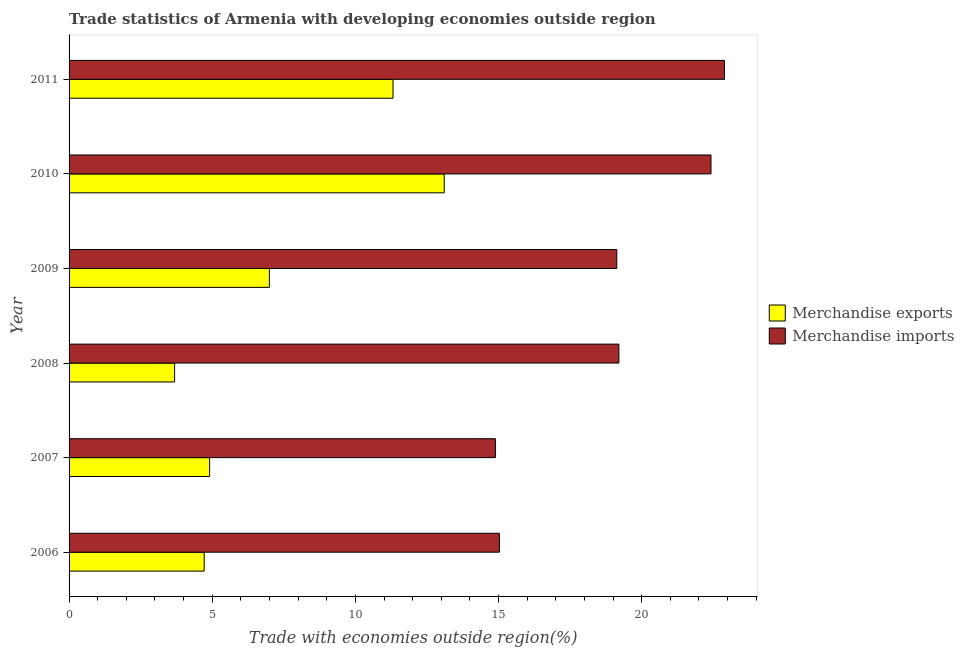How many different coloured bars are there?
Keep it short and to the point. 2. Are the number of bars per tick equal to the number of legend labels?
Make the answer very short. Yes. Are the number of bars on each tick of the Y-axis equal?
Give a very brief answer. Yes. How many bars are there on the 5th tick from the bottom?
Provide a succinct answer. 2. What is the label of the 5th group of bars from the top?
Keep it short and to the point. 2007. What is the merchandise exports in 2006?
Keep it short and to the point. 4.72. Across all years, what is the maximum merchandise imports?
Your answer should be very brief. 22.89. Across all years, what is the minimum merchandise imports?
Ensure brevity in your answer.  14.89. In which year was the merchandise imports maximum?
Provide a succinct answer. 2011. What is the total merchandise exports in the graph?
Offer a terse response. 44.73. What is the difference between the merchandise imports in 2006 and that in 2010?
Your response must be concise. -7.39. What is the difference between the merchandise imports in 2008 and the merchandise exports in 2010?
Offer a very short reply. 6.1. What is the average merchandise imports per year?
Your answer should be compact. 18.93. In the year 2011, what is the difference between the merchandise imports and merchandise exports?
Your response must be concise. 11.58. What is the ratio of the merchandise imports in 2006 to that in 2008?
Offer a terse response. 0.78. What is the difference between the highest and the second highest merchandise imports?
Your answer should be compact. 0.47. What is the difference between the highest and the lowest merchandise imports?
Your response must be concise. 8. In how many years, is the merchandise exports greater than the average merchandise exports taken over all years?
Your answer should be very brief. 2. What does the 2nd bar from the bottom in 2010 represents?
Make the answer very short. Merchandise imports. Are all the bars in the graph horizontal?
Make the answer very short. Yes. Are the values on the major ticks of X-axis written in scientific E-notation?
Your answer should be very brief. No. Does the graph contain grids?
Make the answer very short. No. What is the title of the graph?
Your answer should be very brief. Trade statistics of Armenia with developing economies outside region. Does "Resident workers" appear as one of the legend labels in the graph?
Offer a very short reply. No. What is the label or title of the X-axis?
Keep it short and to the point. Trade with economies outside region(%). What is the Trade with economies outside region(%) in Merchandise exports in 2006?
Your answer should be compact. 4.72. What is the Trade with economies outside region(%) of Merchandise imports in 2006?
Your response must be concise. 15.03. What is the Trade with economies outside region(%) in Merchandise exports in 2007?
Give a very brief answer. 4.91. What is the Trade with economies outside region(%) of Merchandise imports in 2007?
Keep it short and to the point. 14.89. What is the Trade with economies outside region(%) of Merchandise exports in 2008?
Offer a very short reply. 3.69. What is the Trade with economies outside region(%) in Merchandise imports in 2008?
Provide a short and direct response. 19.2. What is the Trade with economies outside region(%) of Merchandise exports in 2009?
Offer a very short reply. 7. What is the Trade with economies outside region(%) in Merchandise imports in 2009?
Your response must be concise. 19.13. What is the Trade with economies outside region(%) in Merchandise exports in 2010?
Your response must be concise. 13.1. What is the Trade with economies outside region(%) of Merchandise imports in 2010?
Your answer should be very brief. 22.42. What is the Trade with economies outside region(%) of Merchandise exports in 2011?
Give a very brief answer. 11.32. What is the Trade with economies outside region(%) in Merchandise imports in 2011?
Ensure brevity in your answer.  22.89. Across all years, what is the maximum Trade with economies outside region(%) of Merchandise exports?
Make the answer very short. 13.1. Across all years, what is the maximum Trade with economies outside region(%) of Merchandise imports?
Offer a terse response. 22.89. Across all years, what is the minimum Trade with economies outside region(%) in Merchandise exports?
Offer a very short reply. 3.69. Across all years, what is the minimum Trade with economies outside region(%) of Merchandise imports?
Your response must be concise. 14.89. What is the total Trade with economies outside region(%) of Merchandise exports in the graph?
Give a very brief answer. 44.73. What is the total Trade with economies outside region(%) of Merchandise imports in the graph?
Make the answer very short. 113.57. What is the difference between the Trade with economies outside region(%) of Merchandise exports in 2006 and that in 2007?
Your response must be concise. -0.19. What is the difference between the Trade with economies outside region(%) of Merchandise imports in 2006 and that in 2007?
Make the answer very short. 0.14. What is the difference between the Trade with economies outside region(%) in Merchandise exports in 2006 and that in 2008?
Offer a terse response. 1.03. What is the difference between the Trade with economies outside region(%) of Merchandise imports in 2006 and that in 2008?
Provide a succinct answer. -4.17. What is the difference between the Trade with economies outside region(%) in Merchandise exports in 2006 and that in 2009?
Offer a very short reply. -2.28. What is the difference between the Trade with economies outside region(%) in Merchandise imports in 2006 and that in 2009?
Make the answer very short. -4.1. What is the difference between the Trade with economies outside region(%) of Merchandise exports in 2006 and that in 2010?
Provide a succinct answer. -8.38. What is the difference between the Trade with economies outside region(%) in Merchandise imports in 2006 and that in 2010?
Keep it short and to the point. -7.39. What is the difference between the Trade with economies outside region(%) in Merchandise exports in 2006 and that in 2011?
Your answer should be very brief. -6.6. What is the difference between the Trade with economies outside region(%) in Merchandise imports in 2006 and that in 2011?
Your answer should be very brief. -7.86. What is the difference between the Trade with economies outside region(%) in Merchandise exports in 2007 and that in 2008?
Your answer should be very brief. 1.22. What is the difference between the Trade with economies outside region(%) of Merchandise imports in 2007 and that in 2008?
Your response must be concise. -4.31. What is the difference between the Trade with economies outside region(%) in Merchandise exports in 2007 and that in 2009?
Keep it short and to the point. -2.09. What is the difference between the Trade with economies outside region(%) of Merchandise imports in 2007 and that in 2009?
Your answer should be compact. -4.24. What is the difference between the Trade with economies outside region(%) of Merchandise exports in 2007 and that in 2010?
Your answer should be very brief. -8.2. What is the difference between the Trade with economies outside region(%) of Merchandise imports in 2007 and that in 2010?
Provide a succinct answer. -7.53. What is the difference between the Trade with economies outside region(%) of Merchandise exports in 2007 and that in 2011?
Make the answer very short. -6.41. What is the difference between the Trade with economies outside region(%) in Merchandise imports in 2007 and that in 2011?
Offer a terse response. -8. What is the difference between the Trade with economies outside region(%) in Merchandise exports in 2008 and that in 2009?
Offer a terse response. -3.31. What is the difference between the Trade with economies outside region(%) in Merchandise imports in 2008 and that in 2009?
Your answer should be very brief. 0.07. What is the difference between the Trade with economies outside region(%) in Merchandise exports in 2008 and that in 2010?
Offer a terse response. -9.42. What is the difference between the Trade with economies outside region(%) in Merchandise imports in 2008 and that in 2010?
Your answer should be compact. -3.22. What is the difference between the Trade with economies outside region(%) in Merchandise exports in 2008 and that in 2011?
Your answer should be compact. -7.63. What is the difference between the Trade with economies outside region(%) in Merchandise imports in 2008 and that in 2011?
Give a very brief answer. -3.69. What is the difference between the Trade with economies outside region(%) of Merchandise exports in 2009 and that in 2010?
Your response must be concise. -6.11. What is the difference between the Trade with economies outside region(%) in Merchandise imports in 2009 and that in 2010?
Ensure brevity in your answer.  -3.29. What is the difference between the Trade with economies outside region(%) of Merchandise exports in 2009 and that in 2011?
Ensure brevity in your answer.  -4.32. What is the difference between the Trade with economies outside region(%) in Merchandise imports in 2009 and that in 2011?
Provide a succinct answer. -3.76. What is the difference between the Trade with economies outside region(%) of Merchandise exports in 2010 and that in 2011?
Your response must be concise. 1.79. What is the difference between the Trade with economies outside region(%) of Merchandise imports in 2010 and that in 2011?
Make the answer very short. -0.47. What is the difference between the Trade with economies outside region(%) of Merchandise exports in 2006 and the Trade with economies outside region(%) of Merchandise imports in 2007?
Make the answer very short. -10.17. What is the difference between the Trade with economies outside region(%) of Merchandise exports in 2006 and the Trade with economies outside region(%) of Merchandise imports in 2008?
Make the answer very short. -14.49. What is the difference between the Trade with economies outside region(%) in Merchandise exports in 2006 and the Trade with economies outside region(%) in Merchandise imports in 2009?
Offer a terse response. -14.41. What is the difference between the Trade with economies outside region(%) in Merchandise exports in 2006 and the Trade with economies outside region(%) in Merchandise imports in 2010?
Your answer should be very brief. -17.7. What is the difference between the Trade with economies outside region(%) in Merchandise exports in 2006 and the Trade with economies outside region(%) in Merchandise imports in 2011?
Offer a very short reply. -18.17. What is the difference between the Trade with economies outside region(%) in Merchandise exports in 2007 and the Trade with economies outside region(%) in Merchandise imports in 2008?
Provide a succinct answer. -14.3. What is the difference between the Trade with economies outside region(%) of Merchandise exports in 2007 and the Trade with economies outside region(%) of Merchandise imports in 2009?
Your answer should be compact. -14.22. What is the difference between the Trade with economies outside region(%) of Merchandise exports in 2007 and the Trade with economies outside region(%) of Merchandise imports in 2010?
Make the answer very short. -17.51. What is the difference between the Trade with economies outside region(%) in Merchandise exports in 2007 and the Trade with economies outside region(%) in Merchandise imports in 2011?
Give a very brief answer. -17.98. What is the difference between the Trade with economies outside region(%) in Merchandise exports in 2008 and the Trade with economies outside region(%) in Merchandise imports in 2009?
Offer a terse response. -15.44. What is the difference between the Trade with economies outside region(%) of Merchandise exports in 2008 and the Trade with economies outside region(%) of Merchandise imports in 2010?
Your response must be concise. -18.74. What is the difference between the Trade with economies outside region(%) of Merchandise exports in 2008 and the Trade with economies outside region(%) of Merchandise imports in 2011?
Offer a terse response. -19.21. What is the difference between the Trade with economies outside region(%) of Merchandise exports in 2009 and the Trade with economies outside region(%) of Merchandise imports in 2010?
Give a very brief answer. -15.42. What is the difference between the Trade with economies outside region(%) of Merchandise exports in 2009 and the Trade with economies outside region(%) of Merchandise imports in 2011?
Your answer should be very brief. -15.9. What is the difference between the Trade with economies outside region(%) in Merchandise exports in 2010 and the Trade with economies outside region(%) in Merchandise imports in 2011?
Ensure brevity in your answer.  -9.79. What is the average Trade with economies outside region(%) of Merchandise exports per year?
Your answer should be compact. 7.46. What is the average Trade with economies outside region(%) of Merchandise imports per year?
Keep it short and to the point. 18.93. In the year 2006, what is the difference between the Trade with economies outside region(%) of Merchandise exports and Trade with economies outside region(%) of Merchandise imports?
Make the answer very short. -10.31. In the year 2007, what is the difference between the Trade with economies outside region(%) of Merchandise exports and Trade with economies outside region(%) of Merchandise imports?
Make the answer very short. -9.98. In the year 2008, what is the difference between the Trade with economies outside region(%) in Merchandise exports and Trade with economies outside region(%) in Merchandise imports?
Your response must be concise. -15.52. In the year 2009, what is the difference between the Trade with economies outside region(%) of Merchandise exports and Trade with economies outside region(%) of Merchandise imports?
Offer a very short reply. -12.13. In the year 2010, what is the difference between the Trade with economies outside region(%) of Merchandise exports and Trade with economies outside region(%) of Merchandise imports?
Ensure brevity in your answer.  -9.32. In the year 2011, what is the difference between the Trade with economies outside region(%) in Merchandise exports and Trade with economies outside region(%) in Merchandise imports?
Your answer should be compact. -11.58. What is the ratio of the Trade with economies outside region(%) in Merchandise exports in 2006 to that in 2007?
Provide a short and direct response. 0.96. What is the ratio of the Trade with economies outside region(%) in Merchandise imports in 2006 to that in 2007?
Your answer should be compact. 1.01. What is the ratio of the Trade with economies outside region(%) of Merchandise exports in 2006 to that in 2008?
Provide a succinct answer. 1.28. What is the ratio of the Trade with economies outside region(%) in Merchandise imports in 2006 to that in 2008?
Keep it short and to the point. 0.78. What is the ratio of the Trade with economies outside region(%) in Merchandise exports in 2006 to that in 2009?
Provide a short and direct response. 0.67. What is the ratio of the Trade with economies outside region(%) in Merchandise imports in 2006 to that in 2009?
Ensure brevity in your answer.  0.79. What is the ratio of the Trade with economies outside region(%) of Merchandise exports in 2006 to that in 2010?
Provide a short and direct response. 0.36. What is the ratio of the Trade with economies outside region(%) in Merchandise imports in 2006 to that in 2010?
Keep it short and to the point. 0.67. What is the ratio of the Trade with economies outside region(%) in Merchandise exports in 2006 to that in 2011?
Ensure brevity in your answer.  0.42. What is the ratio of the Trade with economies outside region(%) in Merchandise imports in 2006 to that in 2011?
Offer a terse response. 0.66. What is the ratio of the Trade with economies outside region(%) of Merchandise exports in 2007 to that in 2008?
Provide a short and direct response. 1.33. What is the ratio of the Trade with economies outside region(%) of Merchandise imports in 2007 to that in 2008?
Your response must be concise. 0.78. What is the ratio of the Trade with economies outside region(%) in Merchandise exports in 2007 to that in 2009?
Ensure brevity in your answer.  0.7. What is the ratio of the Trade with economies outside region(%) of Merchandise imports in 2007 to that in 2009?
Offer a terse response. 0.78. What is the ratio of the Trade with economies outside region(%) of Merchandise exports in 2007 to that in 2010?
Make the answer very short. 0.37. What is the ratio of the Trade with economies outside region(%) in Merchandise imports in 2007 to that in 2010?
Keep it short and to the point. 0.66. What is the ratio of the Trade with economies outside region(%) in Merchandise exports in 2007 to that in 2011?
Your answer should be compact. 0.43. What is the ratio of the Trade with economies outside region(%) of Merchandise imports in 2007 to that in 2011?
Provide a succinct answer. 0.65. What is the ratio of the Trade with economies outside region(%) of Merchandise exports in 2008 to that in 2009?
Provide a succinct answer. 0.53. What is the ratio of the Trade with economies outside region(%) in Merchandise exports in 2008 to that in 2010?
Keep it short and to the point. 0.28. What is the ratio of the Trade with economies outside region(%) in Merchandise imports in 2008 to that in 2010?
Your response must be concise. 0.86. What is the ratio of the Trade with economies outside region(%) in Merchandise exports in 2008 to that in 2011?
Offer a very short reply. 0.33. What is the ratio of the Trade with economies outside region(%) in Merchandise imports in 2008 to that in 2011?
Your response must be concise. 0.84. What is the ratio of the Trade with economies outside region(%) of Merchandise exports in 2009 to that in 2010?
Make the answer very short. 0.53. What is the ratio of the Trade with economies outside region(%) in Merchandise imports in 2009 to that in 2010?
Provide a short and direct response. 0.85. What is the ratio of the Trade with economies outside region(%) in Merchandise exports in 2009 to that in 2011?
Your response must be concise. 0.62. What is the ratio of the Trade with economies outside region(%) in Merchandise imports in 2009 to that in 2011?
Give a very brief answer. 0.84. What is the ratio of the Trade with economies outside region(%) of Merchandise exports in 2010 to that in 2011?
Your response must be concise. 1.16. What is the ratio of the Trade with economies outside region(%) in Merchandise imports in 2010 to that in 2011?
Provide a short and direct response. 0.98. What is the difference between the highest and the second highest Trade with economies outside region(%) of Merchandise exports?
Offer a very short reply. 1.79. What is the difference between the highest and the second highest Trade with economies outside region(%) of Merchandise imports?
Keep it short and to the point. 0.47. What is the difference between the highest and the lowest Trade with economies outside region(%) in Merchandise exports?
Keep it short and to the point. 9.42. What is the difference between the highest and the lowest Trade with economies outside region(%) of Merchandise imports?
Provide a succinct answer. 8. 